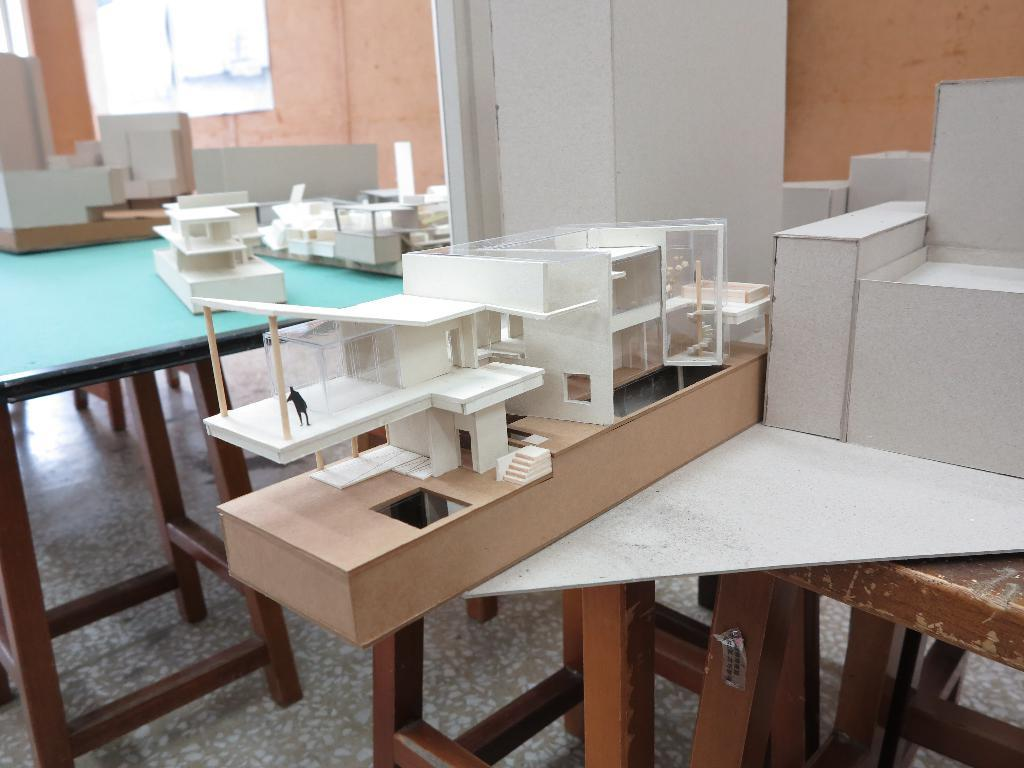What type of objects are in the image? There are miniatures in the image. Where are the miniatures located? The miniatures are on tables. What nation is represented by the miniatures in the image? The image does not provide information about the nation represented by the miniatures. What type of brake system is present on the miniatures in the image? There is no indication of any brake system present on the miniatures in the image. 